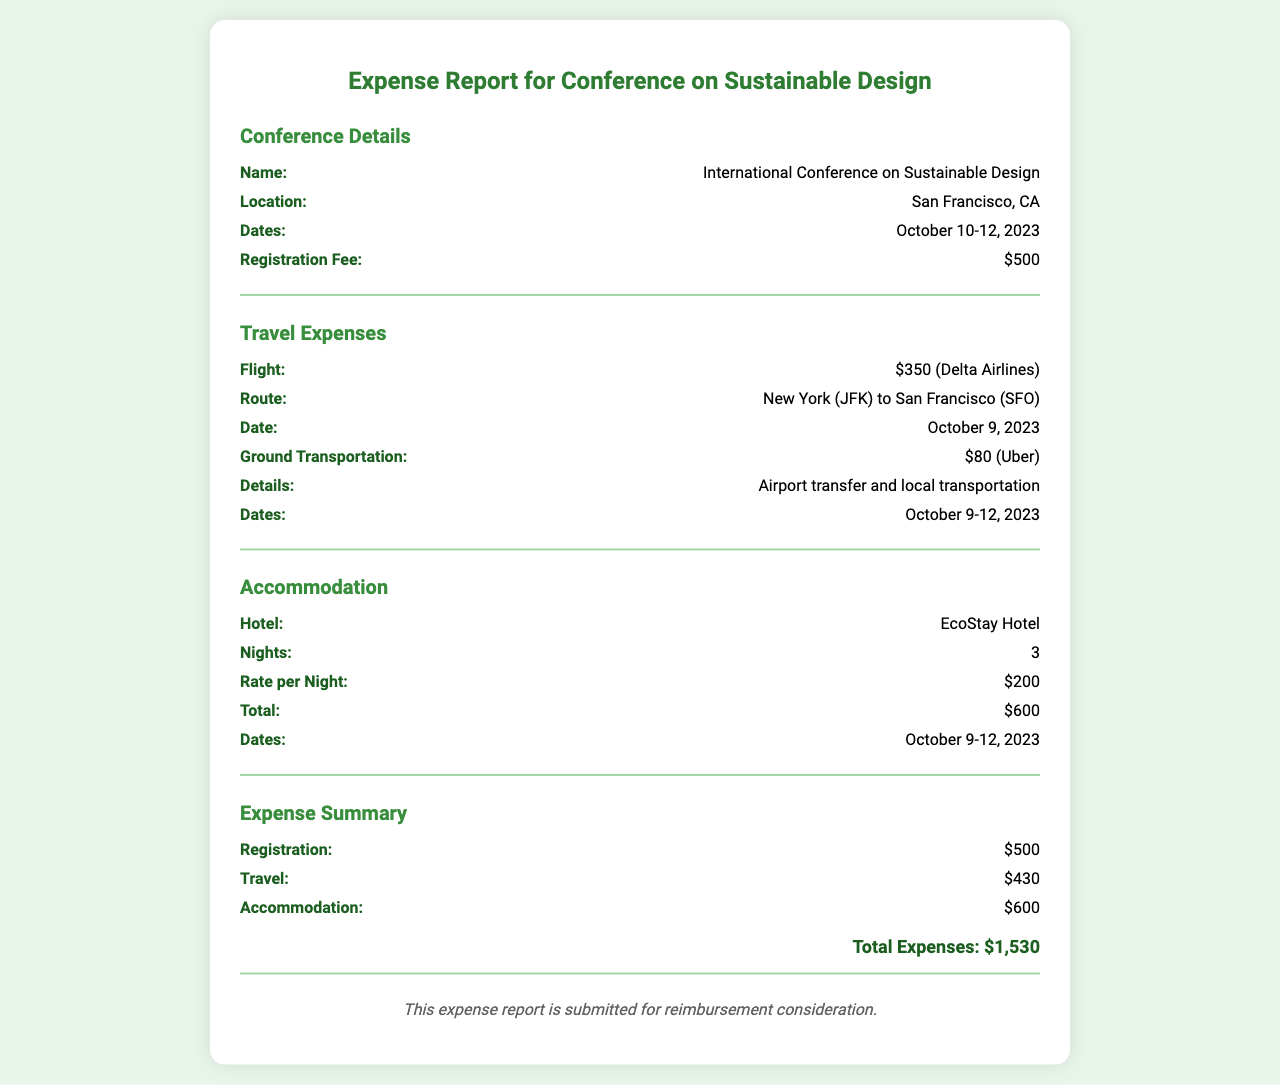What is the name of the conference? The name of the conference is explicitly stated in the document under "Conference Details."
Answer: International Conference on Sustainable Design Where is the conference located? The location of the conference can be found in the section for "Conference Details."
Answer: San Francisco, CA What is the registration fee? The registration fee is listed in the "Conference Details" section.
Answer: $500 How much was spent on travel? The travel expenses are summarized under "Expense Summary" and include details about flights and ground transportation.
Answer: $430 What is the total accommodation cost? The total accommodation cost is provided in the "Accommodation" section.
Answer: $600 How many nights did the accommodation cover? The number of nights for accommodation is stated in the section dedicated to it.
Answer: 3 What was the rate per night for the hotel? The rate per night for the EcoStay Hotel is mentioned in the accommodation section.
Answer: $200 What is the total amount of all expenses? The total expenses is calculated at the end of the "Expense Summary" section.
Answer: $1,530 Which airline was used for the flight? The airline for the flight is mentioned under "Travel Expenses."
Answer: Delta Airlines 